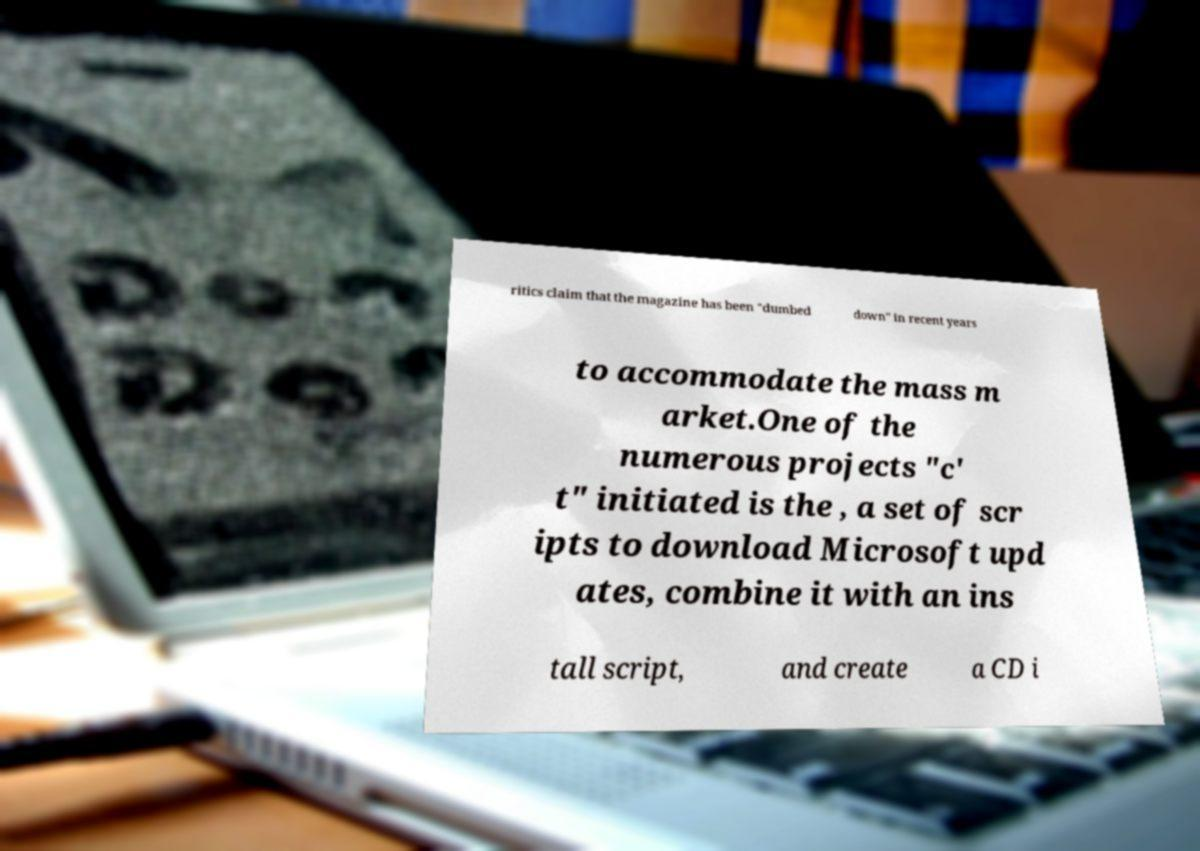Please read and relay the text visible in this image. What does it say? ritics claim that the magazine has been "dumbed down" in recent years to accommodate the mass m arket.One of the numerous projects "c' t" initiated is the , a set of scr ipts to download Microsoft upd ates, combine it with an ins tall script, and create a CD i 